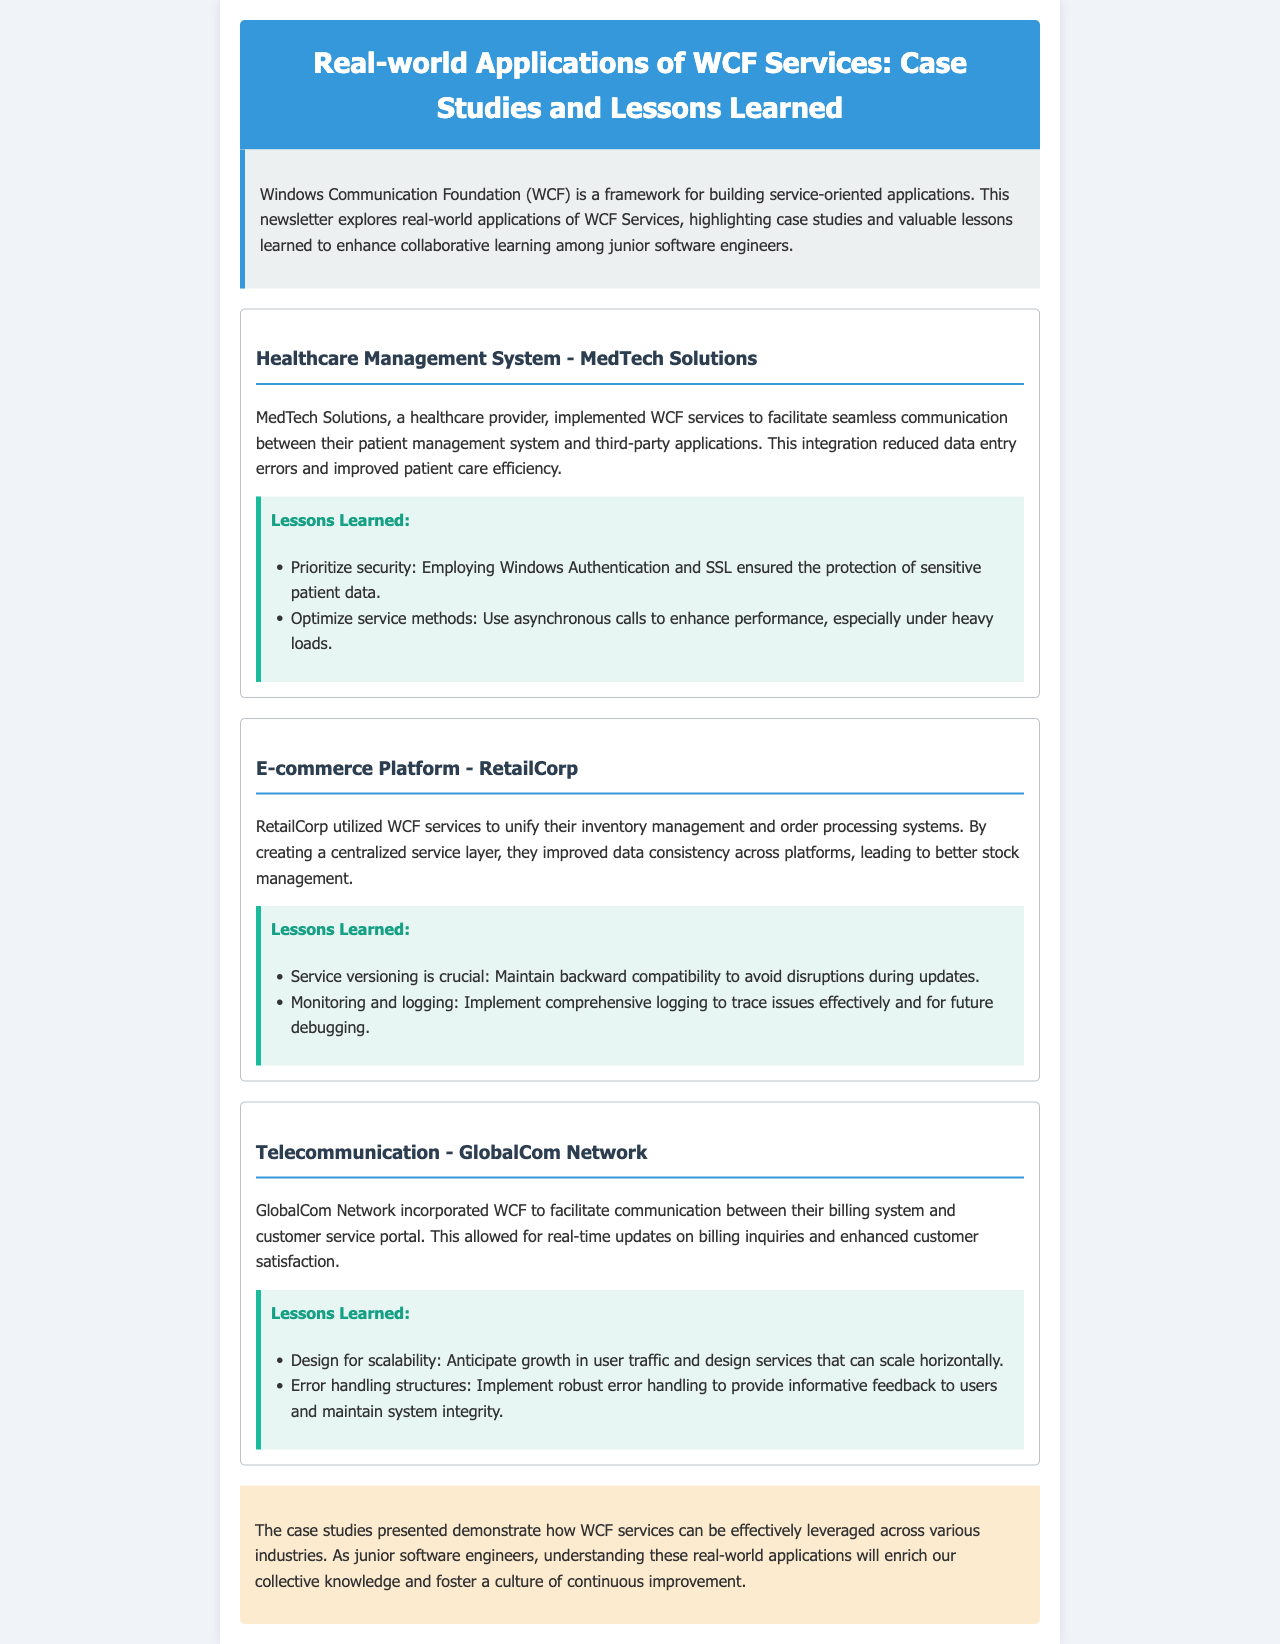What is the title of the newsletter? The title is provided in the header of the document, which is "Real-world Applications of WCF Services: Case Studies and Lessons Learned."
Answer: Real-world Applications of WCF Services: Case Studies and Lessons Learned Who implemented WCF services in the healthcare sector? The healthcare provider mentioned in the document that implemented WCF services is "MedTech Solutions."
Answer: MedTech Solutions What was the main benefit of using WCF services for RetailCorp? The main benefit from the document for RetailCorp is improved data consistency across platforms.
Answer: Improved data consistency How many case studies are mentioned in the newsletter? The document lists a total of three case studies, each pertaining to different sectors.
Answer: Three What lesson from MedTech Solutions emphasizes security? The lesson learned that emphasizes security from MedTech Solutions is employing Windows Authentication and SSL.
Answer: Employing Windows Authentication and SSL What does GlobalCom Network's case study highlight about user growth? The GlobalCom Network case study highlights the importance of designing services to anticipate growth in user traffic.
Answer: Anticipate growth in user traffic What is a key lesson learned regarding service versioning? The document notes that maintaining backward compatibility is crucial for service versioning.
Answer: Maintain backward compatibility What color is used for the headers in the case study sections? The headers in the case study sections are styled with a color that is specifically noted as "#2c3e50."
Answer: #2c3e50 